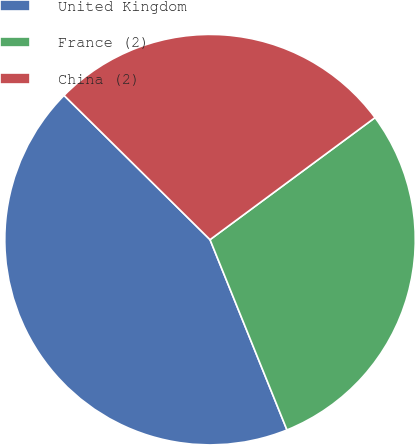Convert chart. <chart><loc_0><loc_0><loc_500><loc_500><pie_chart><fcel>United Kingdom<fcel>France (2)<fcel>China (2)<nl><fcel>43.52%<fcel>29.02%<fcel>27.46%<nl></chart> 